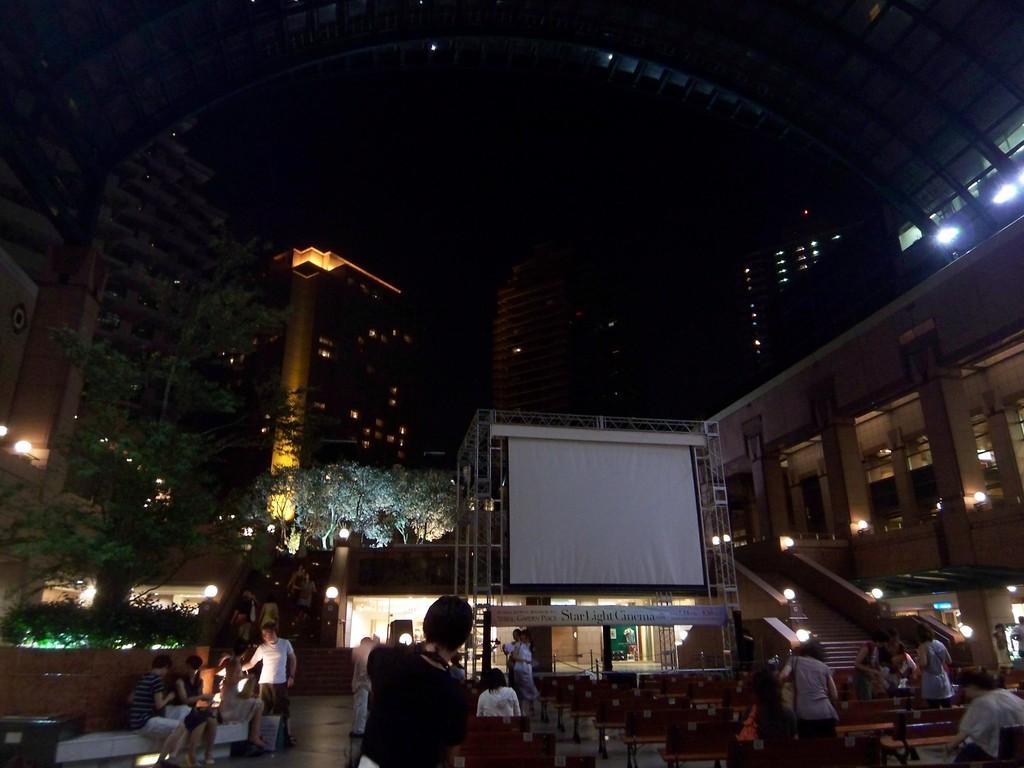Describe this image in one or two sentences. In the foreground of the image there are people. There is a screen. In the background of the image there are buildings, trees. 